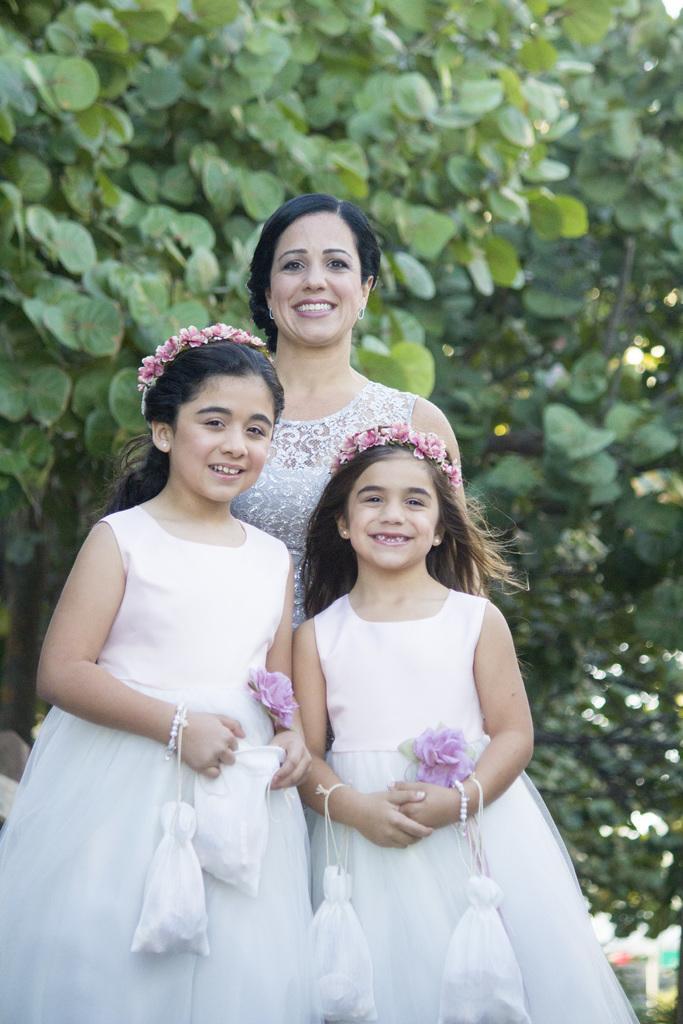How would you summarize this image in a sentence or two? In this picture there are group of people standing and smiling. At the back there is a tree. 